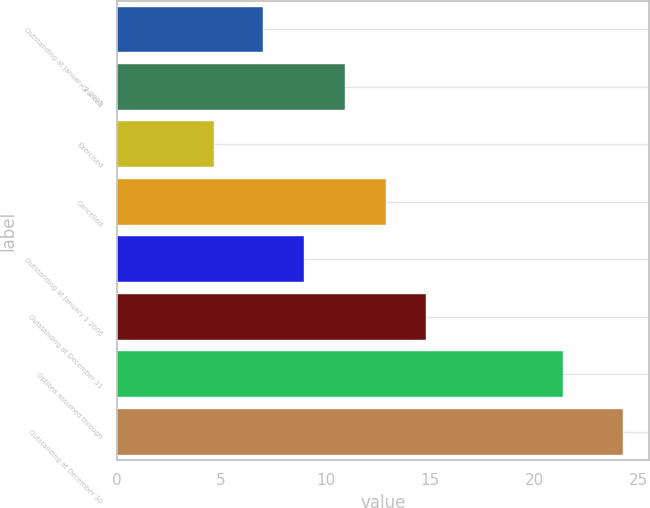Convert chart to OTSL. <chart><loc_0><loc_0><loc_500><loc_500><bar_chart><fcel>Outstanding at January 2 2005<fcel>Granted<fcel>Exercised<fcel>Cancelled<fcel>Outstanding at January 1 2006<fcel>Outstanding at December 31<fcel>Options assumed through<fcel>Outstanding at December 30<nl><fcel>6.99<fcel>10.91<fcel>4.66<fcel>12.87<fcel>8.95<fcel>14.83<fcel>21.37<fcel>24.26<nl></chart> 